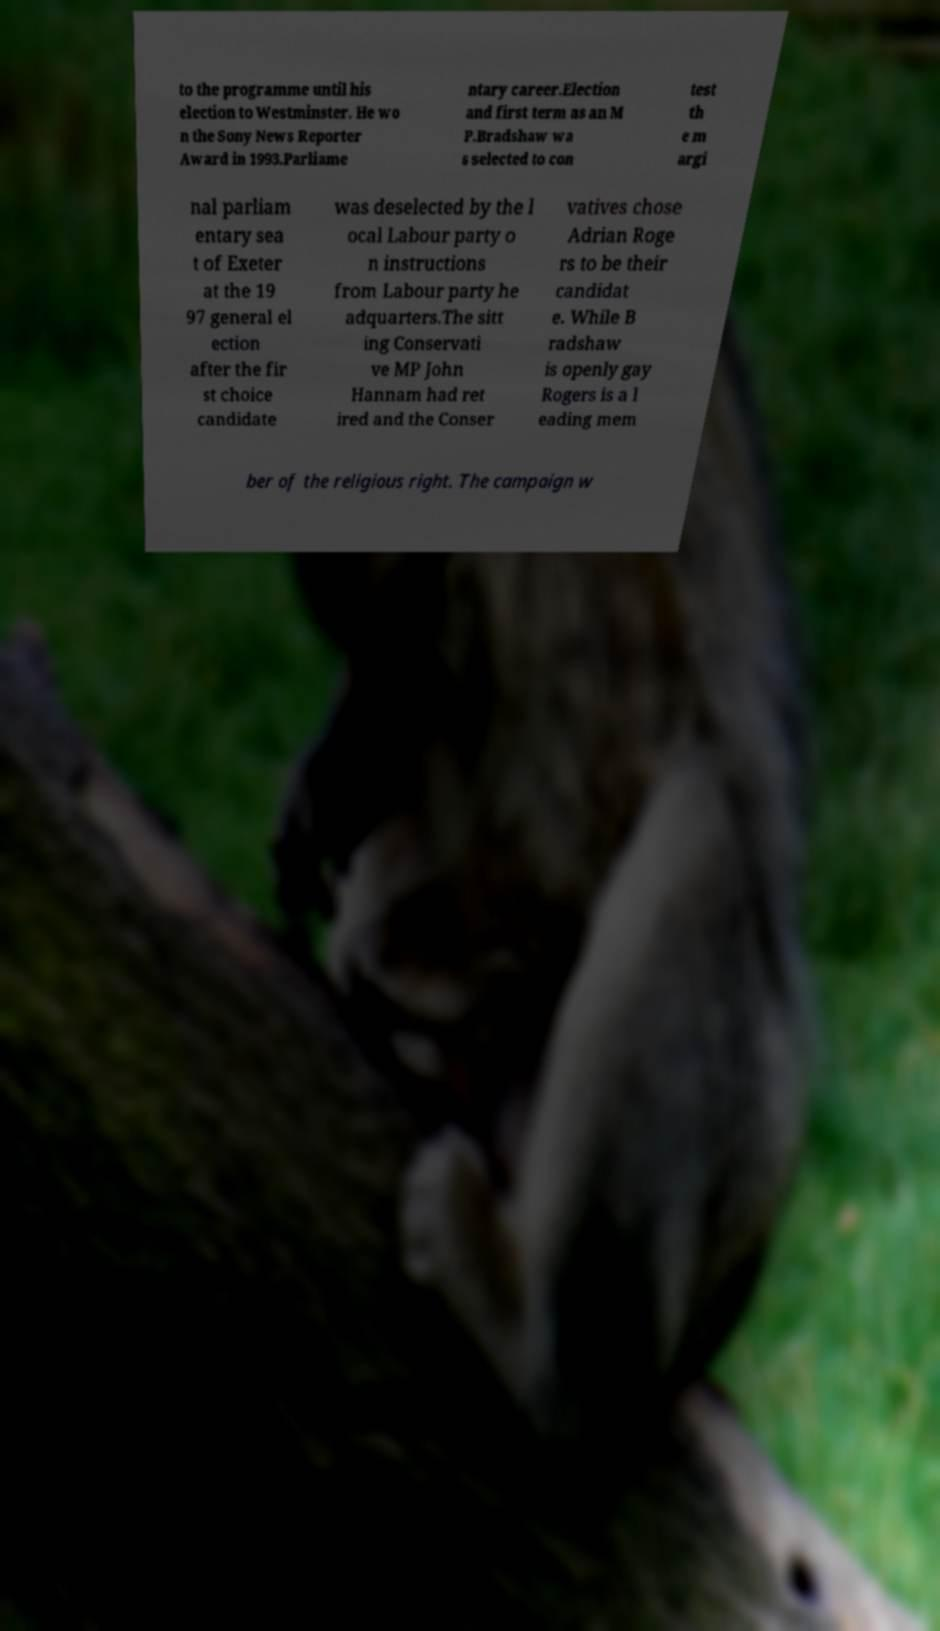Please identify and transcribe the text found in this image. to the programme until his election to Westminster. He wo n the Sony News Reporter Award in 1993.Parliame ntary career.Election and first term as an M P.Bradshaw wa s selected to con test th e m argi nal parliam entary sea t of Exeter at the 19 97 general el ection after the fir st choice candidate was deselected by the l ocal Labour party o n instructions from Labour party he adquarters.The sitt ing Conservati ve MP John Hannam had ret ired and the Conser vatives chose Adrian Roge rs to be their candidat e. While B radshaw is openly gay Rogers is a l eading mem ber of the religious right. The campaign w 